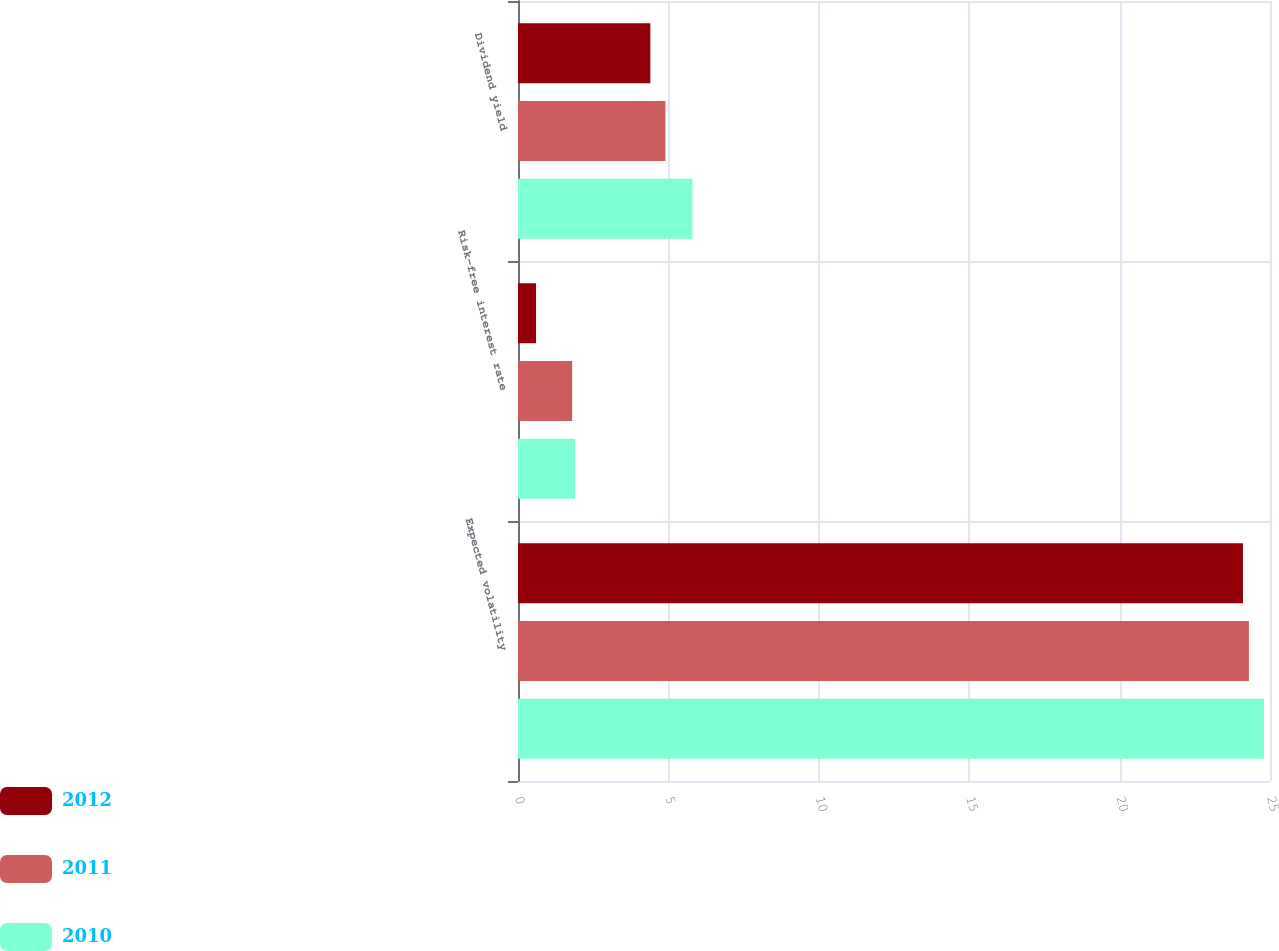Convert chart. <chart><loc_0><loc_0><loc_500><loc_500><stacked_bar_chart><ecel><fcel>Expected volatility<fcel>Risk-free interest rate<fcel>Dividend yield<nl><fcel>2012<fcel>24.1<fcel>0.6<fcel>4.4<nl><fcel>2011<fcel>24.3<fcel>1.8<fcel>4.9<nl><fcel>2010<fcel>24.8<fcel>1.9<fcel>5.8<nl></chart> 